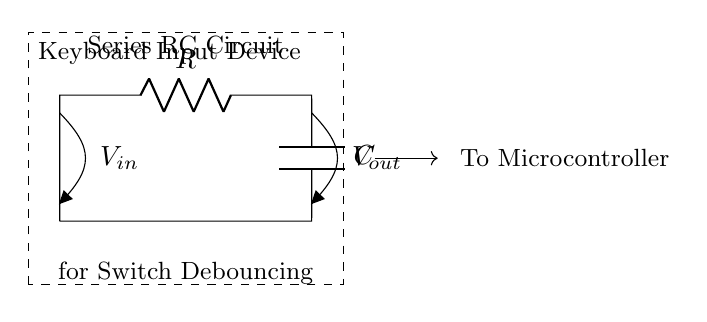What type of circuit is shown? The circuit is a series RC circuit, which comprises a resistor (R) and a capacitor (C) connected in series. The term "series" indicates the components are connected one after the other, allowing the same current to flow through both components.
Answer: series RC circuit What are the components in this circuit? The components in the circuit are a resistor (R) and a capacitor (C). These are clearly labeled in the diagram with their respective symbols and values should be specified in the design.
Answer: resistor and capacitor What is the purpose of the series RC circuit? The purpose is debouncing switches in keyboard input devices. Debouncing is necessary to prevent false triggers caused by mechanical bouncing when a switch is pressed or released, ensuring a clean transition in signal.
Answer: debouncing switches What is the output voltage labeled as? The output voltage is labeled as V out, which indicates the potential difference measured across the capacitor in the circuit. This output voltage will change as the capacitor charges and discharges during switch transitions.
Answer: V out How does the capacitor behave in this circuit when the switch is pressed? When the switch is pressed, the capacitor will begin to charge, causing the voltage across the capacitor to rise gradually rather than instantaneously, which aids in avoiding false triggers. This behavior is governed by the time constant of the circuit, influenced by both the resistor and capacitor values.
Answer: It charges gradually What happens if the resistance is increased in this circuit? If the resistance is increased, the time constant (τ = R*C) of the circuit will increase, meaning the capacitor will take longer to charge and discharge. This leads to a longer debounce time, which could improve reliability in detecting switch presses by reducing false signals.
Answer: Time constant increases What role does the microcontroller play in this circuit? The microcontroller interprets the output signal (V out) from the RC circuit to determine the state of the switch. It reads the changing voltage level as the capacitor transitions from low to high voltage or vice versa, providing a reliable input for processing keystrokes.
Answer: Interprets switch state 